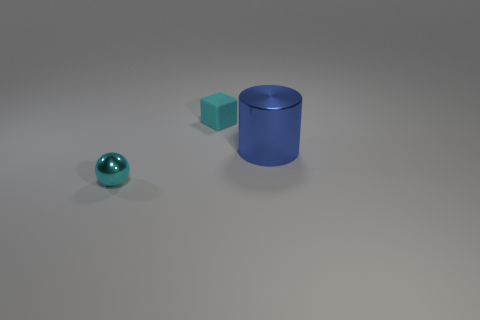There is a tiny cyan thing in front of the small thing that is behind the metallic cylinder; what number of tiny metallic spheres are right of it?
Offer a terse response. 0. What is the color of the metal thing that is the same size as the block?
Keep it short and to the point. Cyan. What number of other things are there of the same color as the big metal cylinder?
Your answer should be very brief. 0. Are there more cyan shiny spheres that are right of the blue shiny object than cyan spheres?
Offer a terse response. No. Is the blue thing made of the same material as the tiny cyan ball?
Provide a succinct answer. Yes. What number of things are objects that are in front of the small matte object or big yellow shiny objects?
Provide a short and direct response. 2. How many other objects are there of the same size as the blue cylinder?
Provide a succinct answer. 0. Is the number of big blue metallic objects that are on the right side of the cyan ball the same as the number of metallic cylinders on the left side of the blue shiny object?
Provide a short and direct response. No. Are there any other things that are the same shape as the large blue shiny object?
Make the answer very short. No. There is a thing that is in front of the big metal cylinder; is it the same color as the large cylinder?
Give a very brief answer. No. 